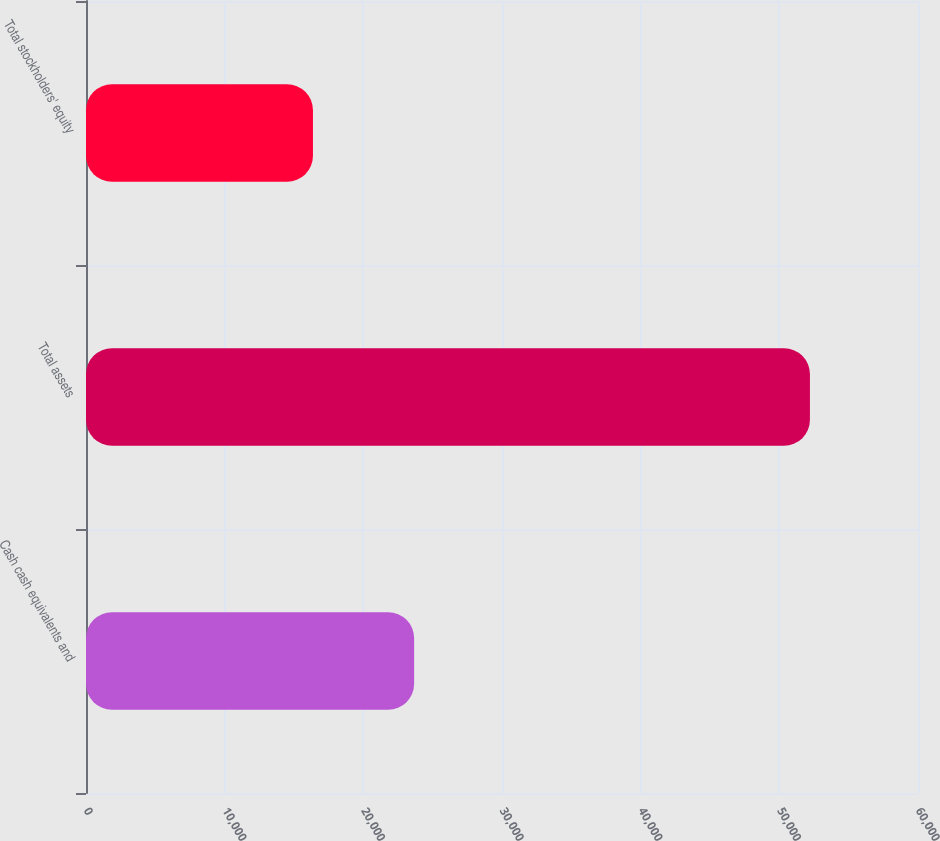Convert chart to OTSL. <chart><loc_0><loc_0><loc_500><loc_500><bar_chart><fcel>Cash cash equivalents and<fcel>Total assets<fcel>Total stockholders' equity<nl><fcel>23663<fcel>52207<fcel>16367<nl></chart> 